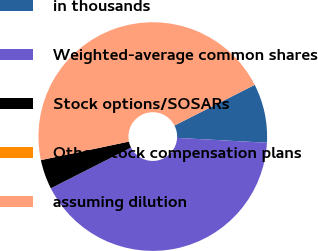Convert chart to OTSL. <chart><loc_0><loc_0><loc_500><loc_500><pie_chart><fcel>in thousands<fcel>Weighted-average common shares<fcel>Stock options/SOSARs<fcel>Other stock compensation plans<fcel>assuming dilution<nl><fcel>8.33%<fcel>41.67%<fcel>4.17%<fcel>0.0%<fcel>45.83%<nl></chart> 